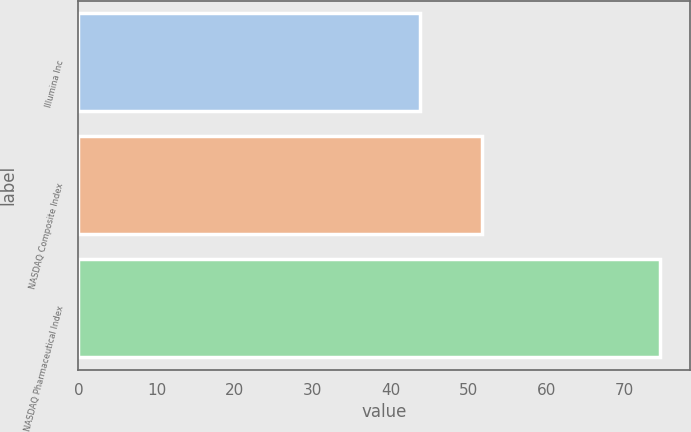Convert chart to OTSL. <chart><loc_0><loc_0><loc_500><loc_500><bar_chart><fcel>Illumina Inc<fcel>NASDAQ Composite Index<fcel>NASDAQ Pharmaceutical Index<nl><fcel>43.81<fcel>51.73<fcel>74.57<nl></chart> 